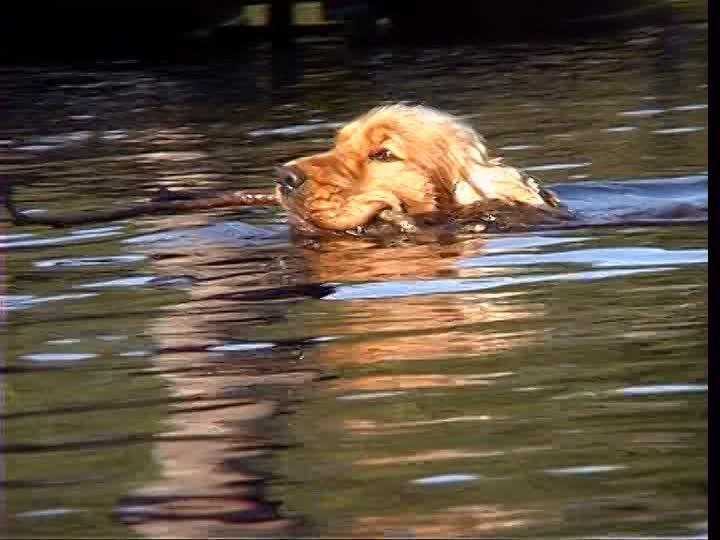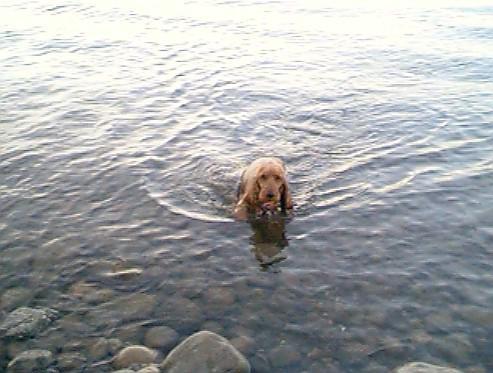The first image is the image on the left, the second image is the image on the right. For the images displayed, is the sentence "An image shows a dog swimming leftward with a stick-shaped object in its mouth." factually correct? Answer yes or no. Yes. 